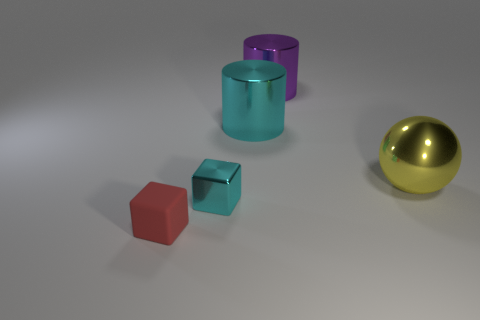Is there anything else that has the same color as the small shiny block?
Provide a short and direct response. Yes. Is the number of tiny cyan things that are to the left of the small red rubber cube less than the number of small metal things?
Your answer should be very brief. Yes. What material is the tiny red object that is the same shape as the small cyan metallic thing?
Provide a short and direct response. Rubber. There is a big metallic object that is behind the big sphere and in front of the large purple metal thing; what is its shape?
Ensure brevity in your answer.  Cylinder. There is a large purple object that is the same material as the yellow ball; what shape is it?
Provide a short and direct response. Cylinder. There is a red cube that is to the left of the big purple metallic thing; what material is it?
Give a very brief answer. Rubber. There is a cube behind the red rubber block; is its size the same as the purple metallic thing that is to the left of the yellow thing?
Give a very brief answer. No. What is the color of the large sphere?
Your answer should be very brief. Yellow. Does the cyan thing behind the cyan block have the same shape as the purple object?
Keep it short and to the point. Yes. What is the material of the tiny red object?
Make the answer very short. Rubber. 